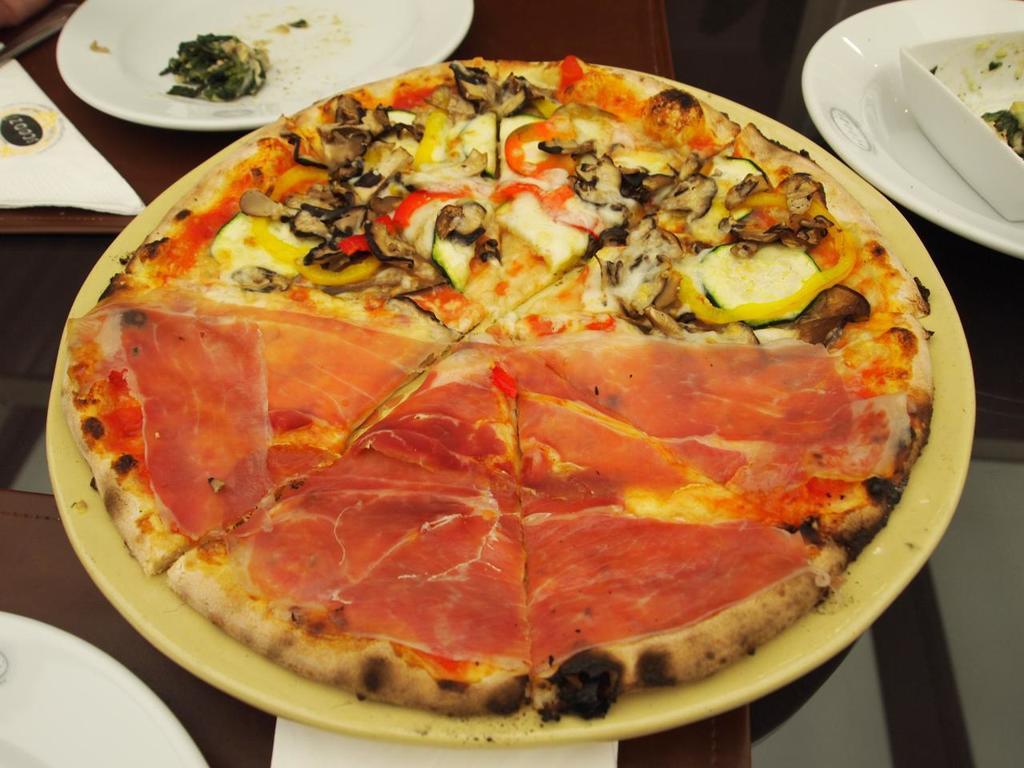Can you describe this image briefly? In this picture we can see a table there are some plates, tissue papers present on the table, we can see a pizza present in this plate. 